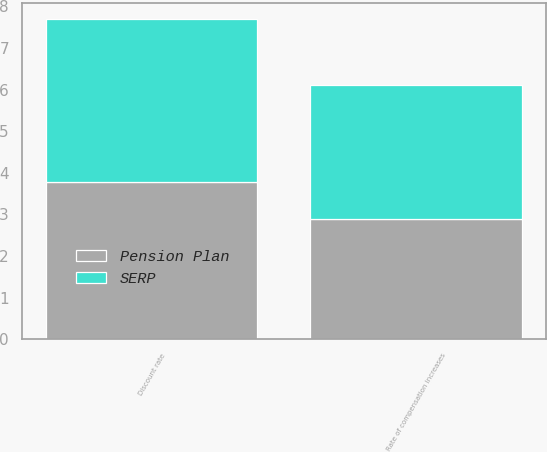Convert chart. <chart><loc_0><loc_0><loc_500><loc_500><stacked_bar_chart><ecel><fcel>Discount rate<fcel>Rate of compensation increases<nl><fcel>SERP<fcel>3.93<fcel>3.23<nl><fcel>Pension Plan<fcel>3.77<fcel>2.89<nl></chart> 